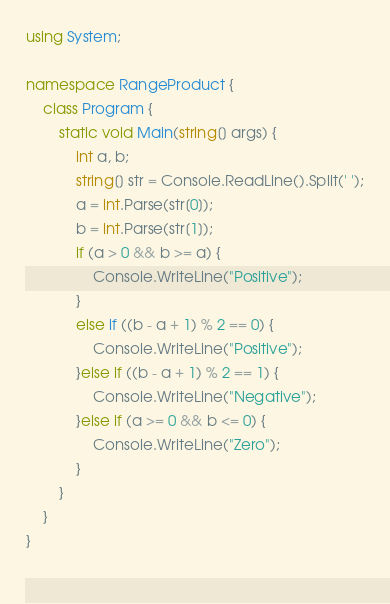<code> <loc_0><loc_0><loc_500><loc_500><_C#_>using System;

namespace RangeProduct {
    class Program {
        static void Main(string[] args) {
            int a, b;
            string[] str = Console.ReadLine().Split(' ');
            a = int.Parse(str[0]);
            b = int.Parse(str[1]);
            if (a > 0 && b >= a) {
                Console.WriteLine("Positive");
            }
            else if ((b - a + 1) % 2 == 0) {
                Console.WriteLine("Positive");
            }else if ((b - a + 1) % 2 == 1) {
                Console.WriteLine("Negative");
            }else if (a >= 0 && b <= 0) {
                Console.WriteLine("Zero");
            }
        }
    }
}
 </code> 